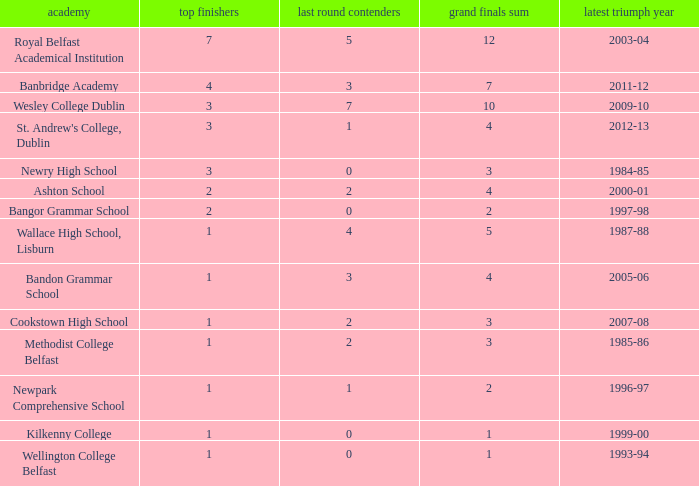What is the name of the school where the year of last win is 1985-86? Methodist College Belfast. 